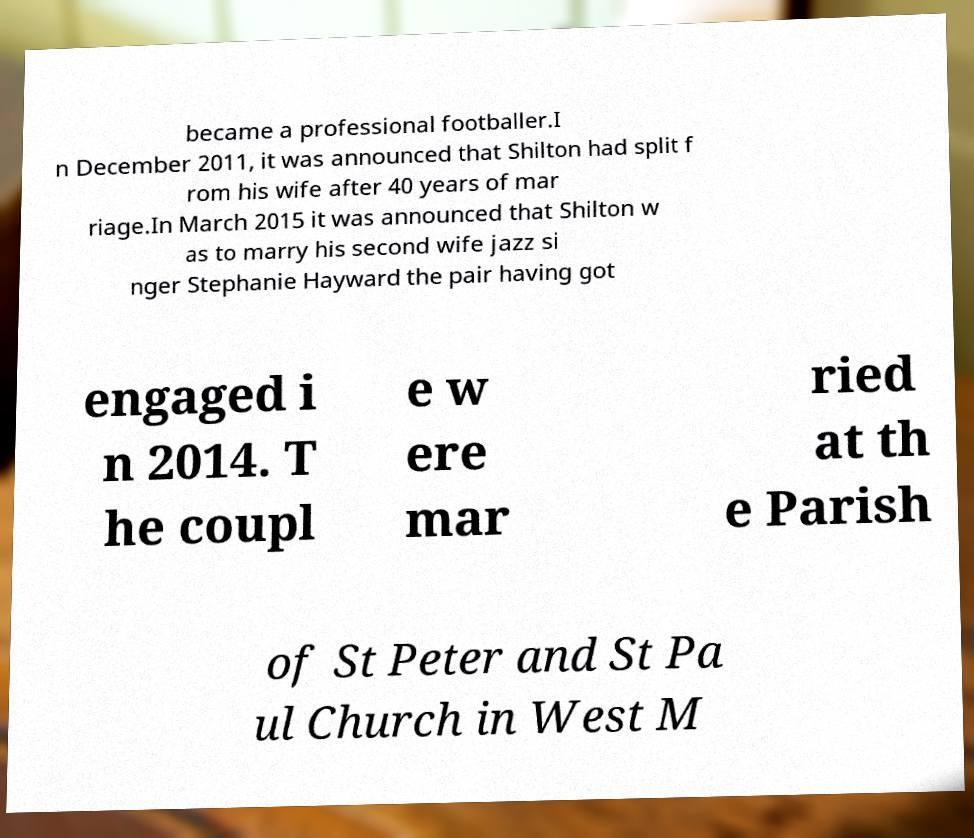Could you assist in decoding the text presented in this image and type it out clearly? became a professional footballer.I n December 2011, it was announced that Shilton had split f rom his wife after 40 years of mar riage.In March 2015 it was announced that Shilton w as to marry his second wife jazz si nger Stephanie Hayward the pair having got engaged i n 2014. T he coupl e w ere mar ried at th e Parish of St Peter and St Pa ul Church in West M 